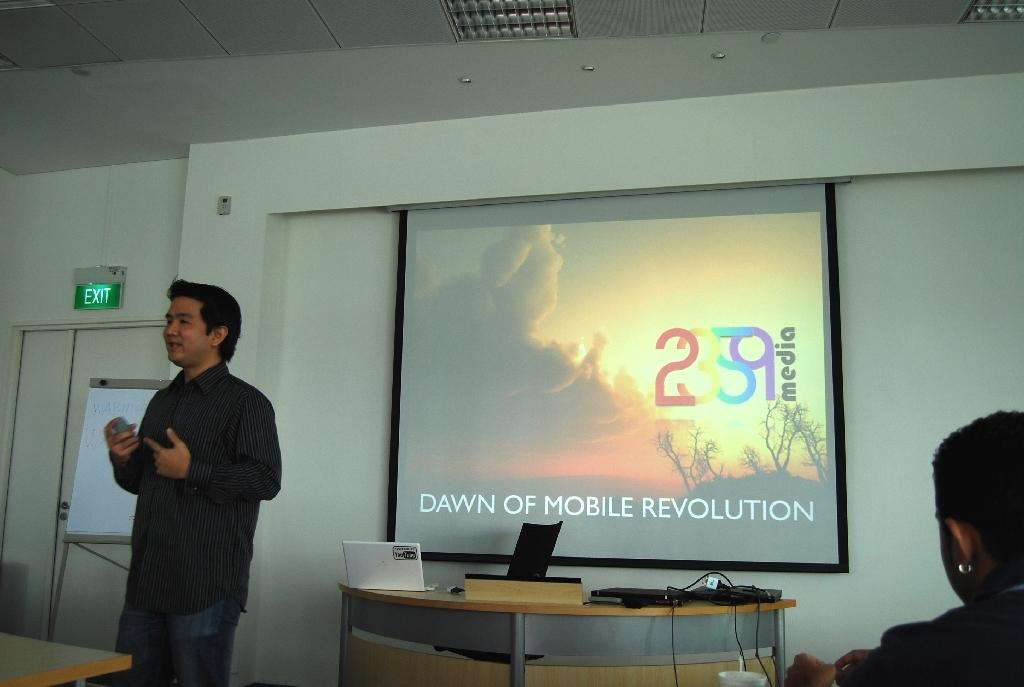Who is the main subject in the image? There is a man in the image. What is the man doing in the image? The man is speaking to people. What object is the man holding while speaking? The man is holding a microphone. What can be seen behind the man? There is a screen behind the man. Can you tell me how many friends the man has in the image? The provided facts do not mention any friends, so it is impossible to determine the number of friends the man has in the image. 